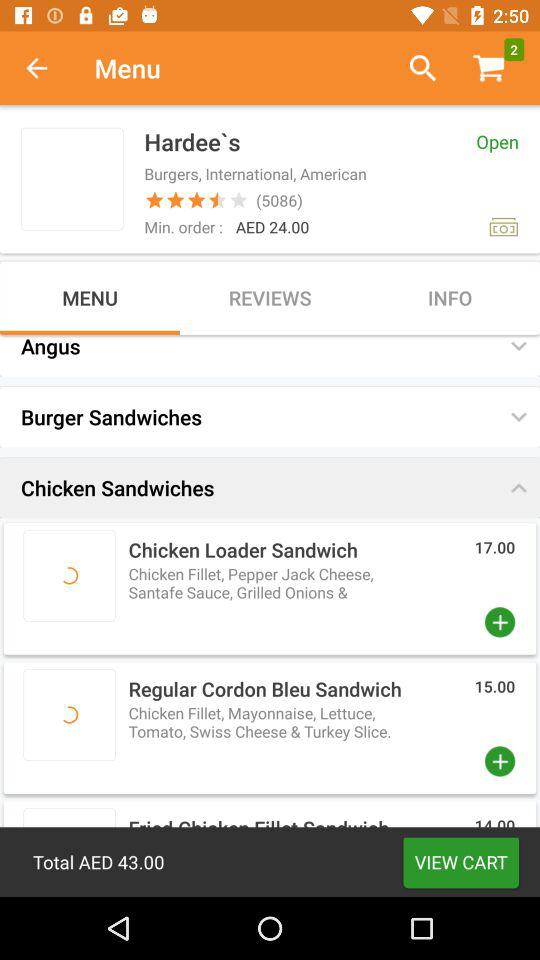How much total AED are in the cart?
When the provided information is insufficient, respond with <no answer>. <no answer> 